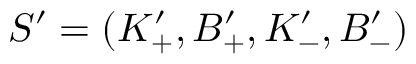<formula> <loc_0><loc_0><loc_500><loc_500>S ^ { \prime } = ( K _ { + } ^ { \prime } , B _ { + } ^ { \prime } , K _ { - } ^ { \prime } , B _ { - } ^ { \prime } )</formula> 